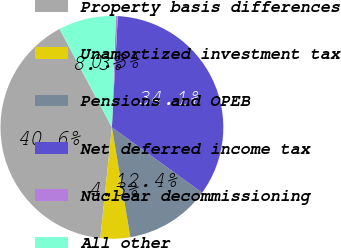Convert chart. <chart><loc_0><loc_0><loc_500><loc_500><pie_chart><fcel>Property basis differences<fcel>Unamortized investment tax<fcel>Pensions and OPEB<fcel>Net deferred income tax<fcel>Nuclear decommissioning<fcel>All other<nl><fcel>40.56%<fcel>4.31%<fcel>12.37%<fcel>34.13%<fcel>0.28%<fcel>8.34%<nl></chart> 